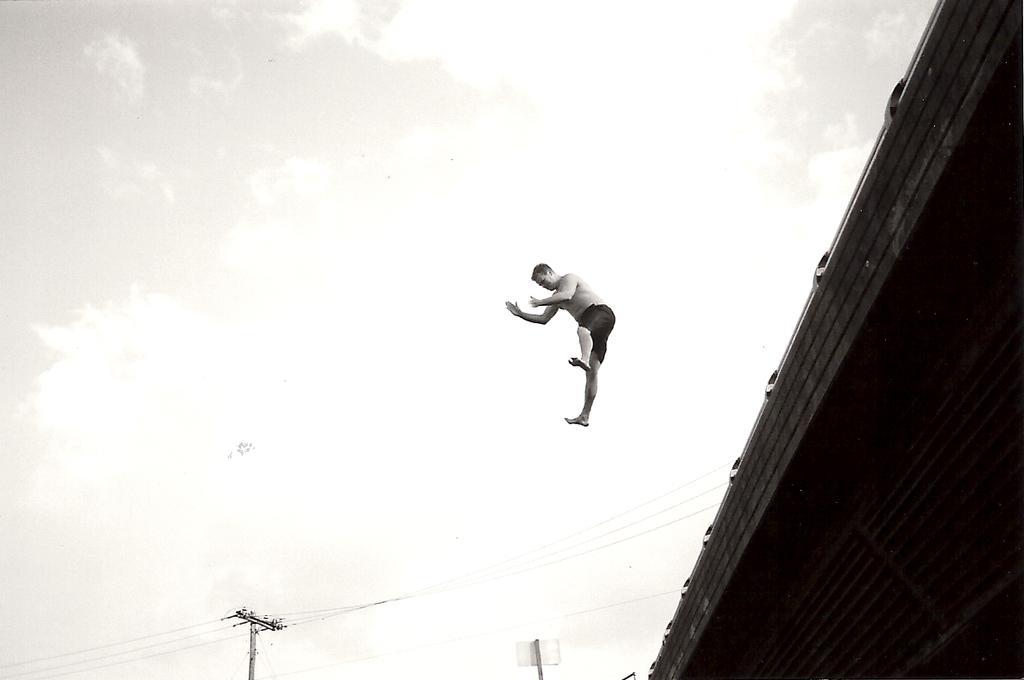Could you give a brief overview of what you see in this image? In this image I can see the person in the air. To the side of the person I can see the building and the current pole. In the background I can see the clouds and the sky. 